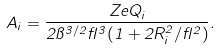<formula> <loc_0><loc_0><loc_500><loc_500>A _ { i } = \frac { Z e Q _ { i } } { 2 \pi ^ { 3 / 2 } \gamma ^ { 3 } ( 1 + 2 R _ { i } ^ { 2 } / \gamma ^ { 2 } ) } .</formula> 